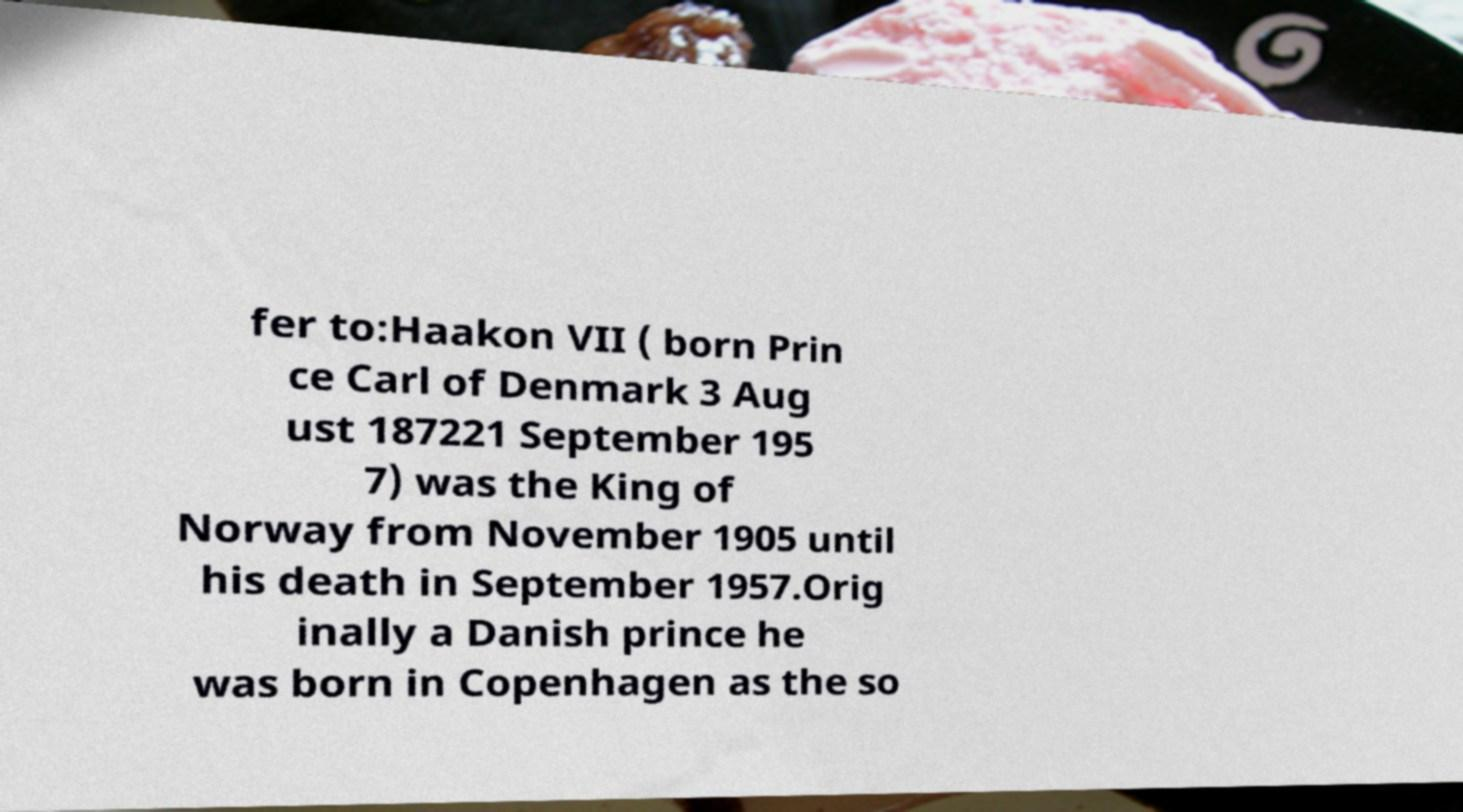There's text embedded in this image that I need extracted. Can you transcribe it verbatim? fer to:Haakon VII ( born Prin ce Carl of Denmark 3 Aug ust 187221 September 195 7) was the King of Norway from November 1905 until his death in September 1957.Orig inally a Danish prince he was born in Copenhagen as the so 